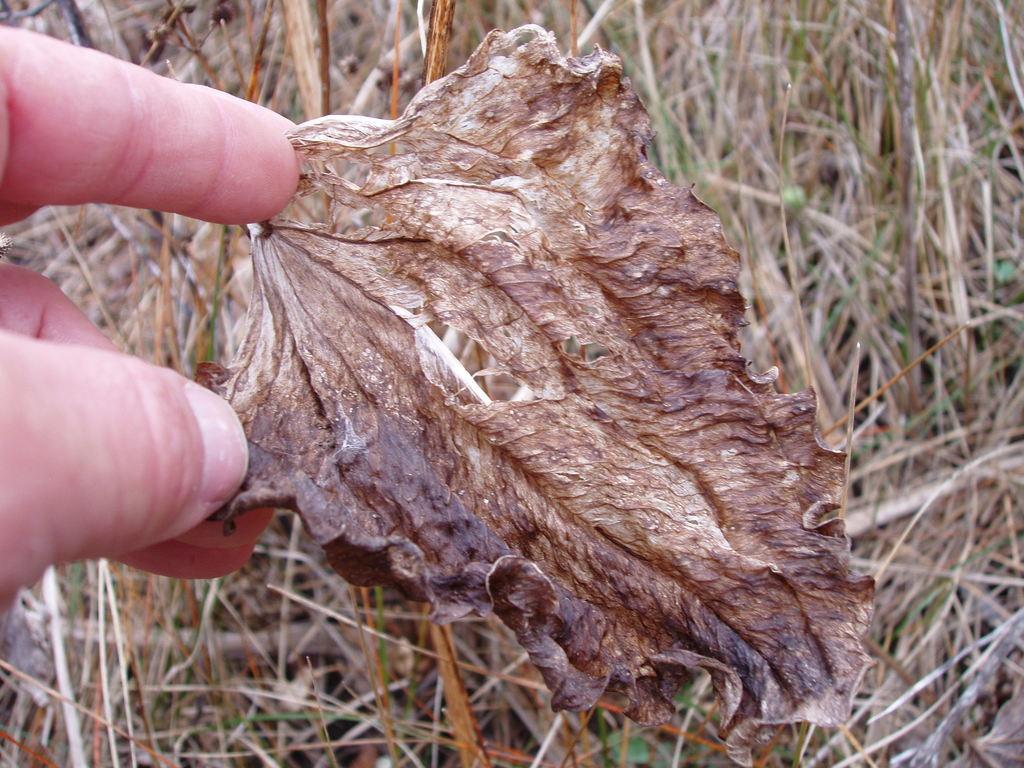How would you summarize this image in a sentence or two? In the front of the image we can see fingers of a person holding a dried leaf. In the background of the image there is grass.   